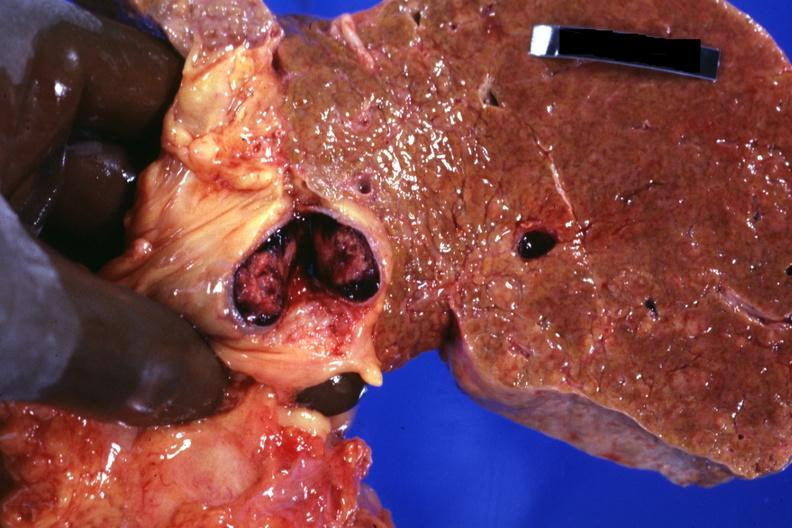what is frontal slab of liver showing?
Answer the question using a single word or phrase. Cirrhosis very well that appears to be micronodular and cross sectioned portal vein with obvious thrombus very good photo 